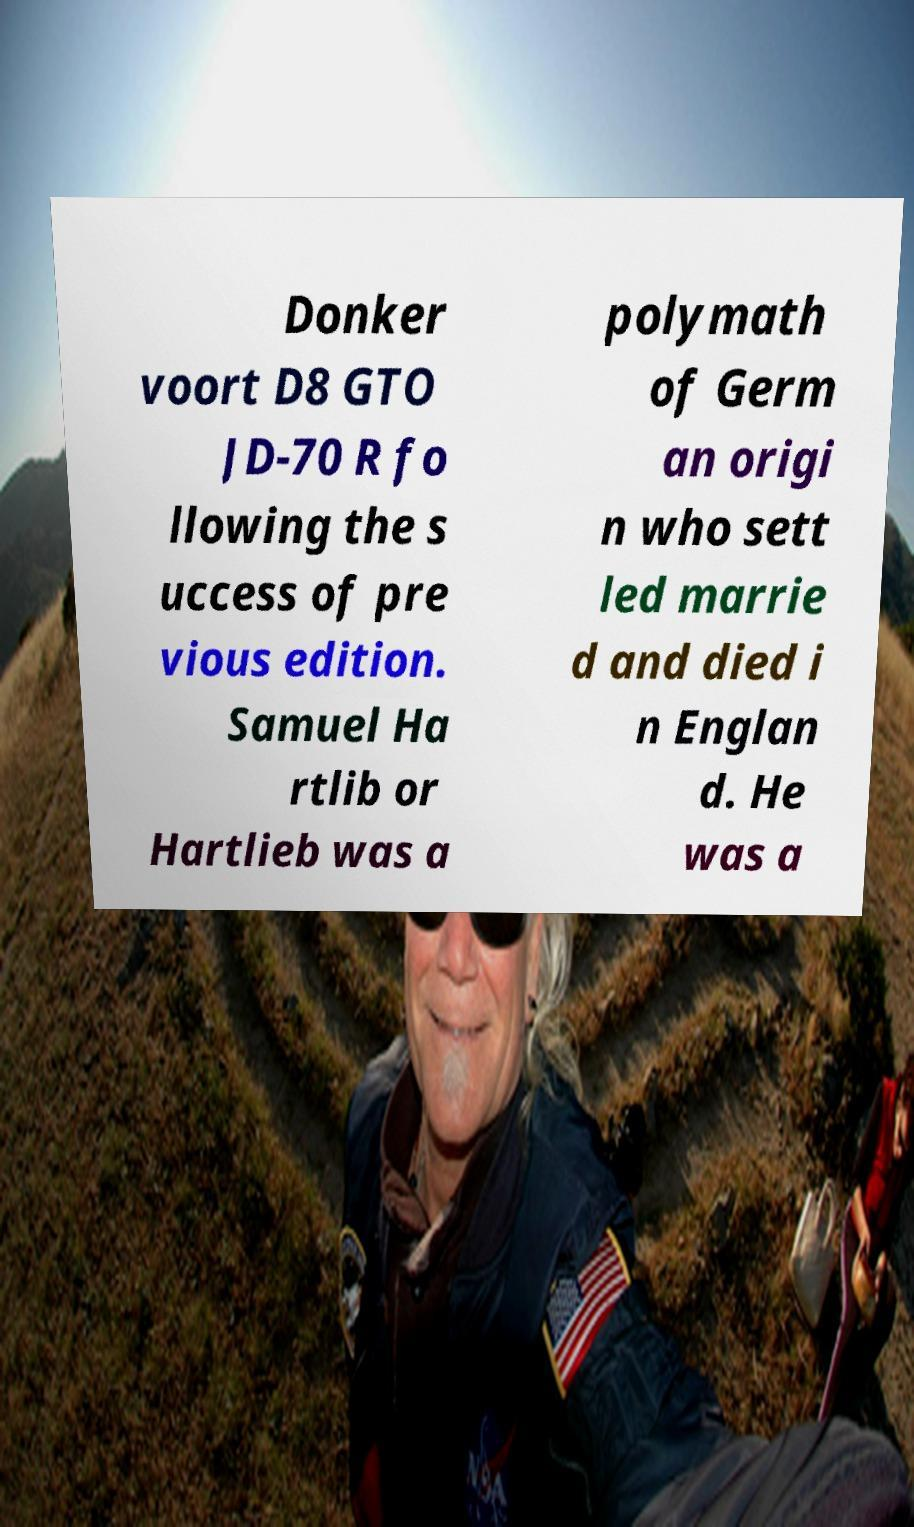I need the written content from this picture converted into text. Can you do that? Donker voort D8 GTO JD-70 R fo llowing the s uccess of pre vious edition. Samuel Ha rtlib or Hartlieb was a polymath of Germ an origi n who sett led marrie d and died i n Englan d. He was a 